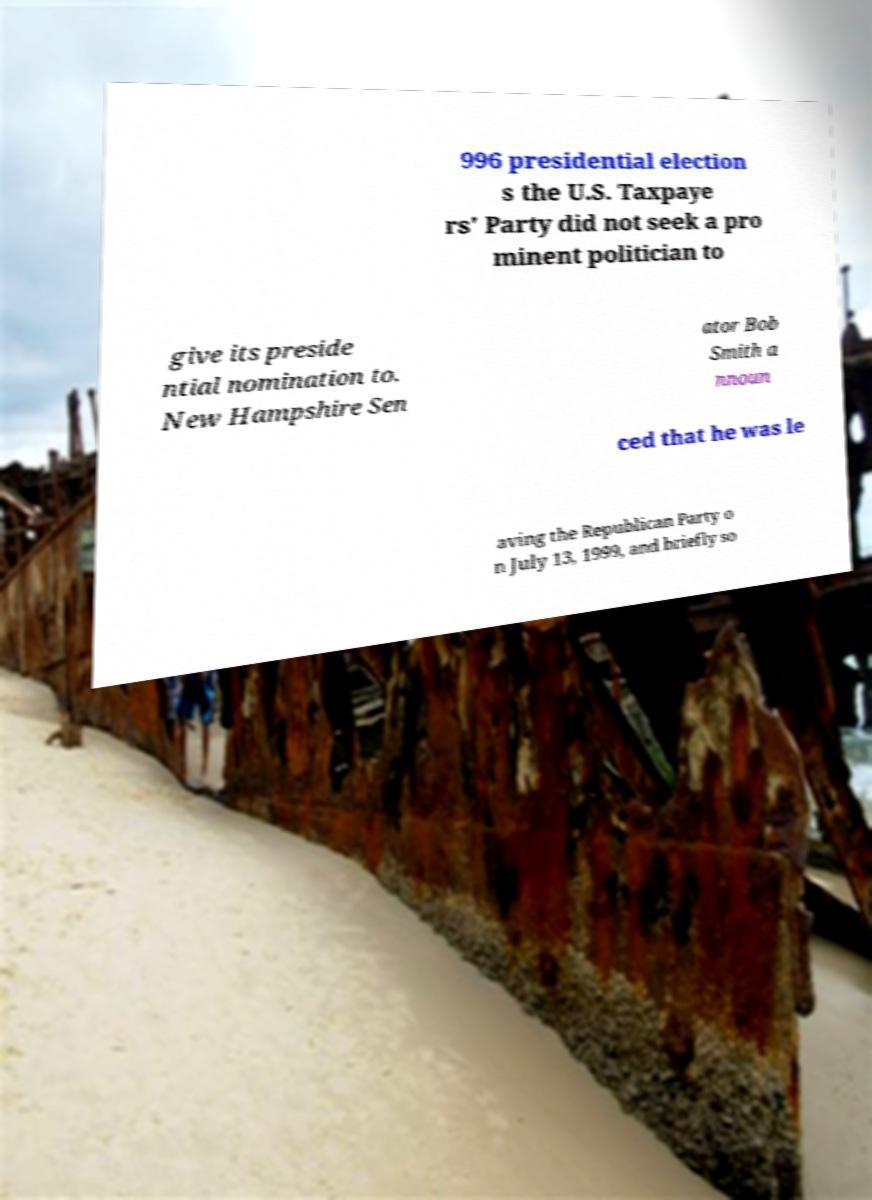For documentation purposes, I need the text within this image transcribed. Could you provide that? 996 presidential election s the U.S. Taxpaye rs' Party did not seek a pro minent politician to give its preside ntial nomination to. New Hampshire Sen ator Bob Smith a nnoun ced that he was le aving the Republican Party o n July 13, 1999, and briefly so 